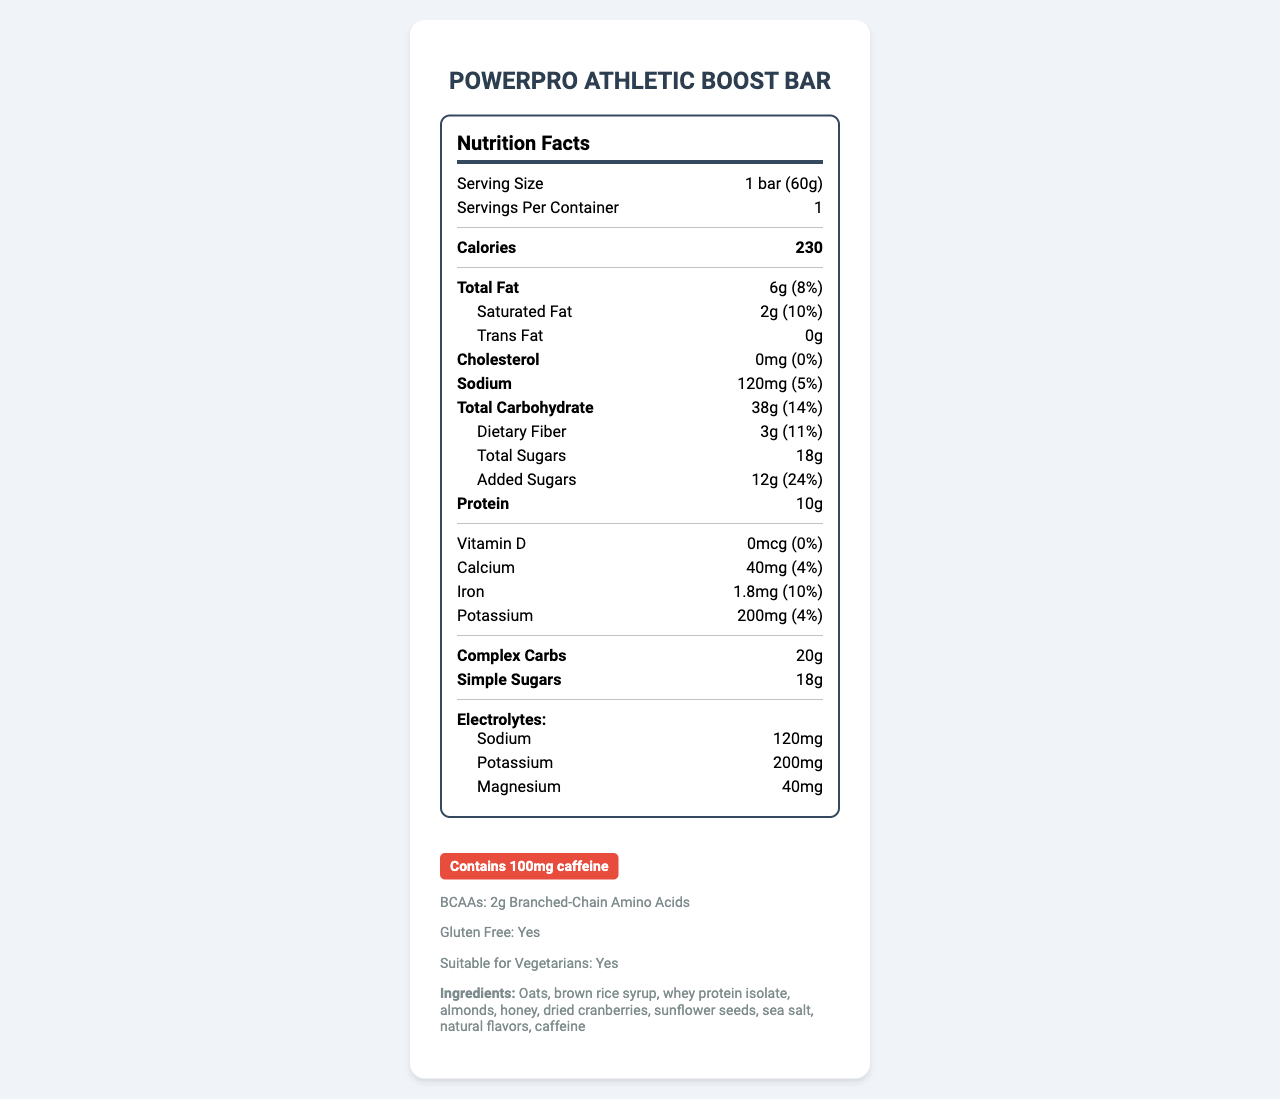what is the serving size of the PowerPro Athletic Boost Bar? The document states that the serving size is 1 bar weighing 60 grams.
Answer: 1 bar (60g) how many calories are in one serving of the energy bar? The document lists the calories per serving as 230.
Answer: 230 how much added sugar is in one serving of the energy bar? The document indicates that the added sugars amount to 12 grams per serving.
Answer: 12g how much protein does one PowerPro Athletic Boost Bar contain? The document states the protein content as 10 grams.
Answer: 10g List the electrolytes provided in this energy bar. The document specifies electrolytes as 120mg sodium, 200mg potassium, and 40mg magnesium.
Answer: Sodium, Potassium, Magnesium how much caffeine is contained in this bar? The additional information section highlights a 100mg caffeine content as part of its pre-workout boost.
Answer: 100mg what is the total carbohydrate content per serving? The document lists the total carbohydrate content as 38 grams.
Answer: 38g how much dietary fiber is in one PowerPro Athletic Boost Bar? The document states that the dietary fiber content is 3 grams.
Answer: 3g what percentage of the daily value is the saturated fat content? The document indicates that the saturated fat content is 10% of the daily value.
Answer: 10% Is the PowerPro Athletic Boost Bar gluten-free? The additional information specifies that the bar is gluten-free.
Answer: Yes how many servings are there per container? According to the document, there is 1 serving per container.
Answer: 1 What is the amount of simple sugars in one serving? A. 10g B. 15g C. 18g The document indicates that the amount of simple sugars in one serving is 18 grams.
Answer: C Which mineral has the highest percentage of the daily value in this bar? A. Calcium B. Iron C. Potassium Iron at 10% has the highest percentage of the daily value compared to calcium at 4% and potassium at 4%.
Answer: B Does this energy bar contain any cholesterol? The document states that the cholesterol content is 0mg, which is 0% of the daily value.
Answer: No Describe the main idea of the document. The document is essentially a comprehensive Nutrition Facts Label and additional information for the PowerPro Athletic Boost Bar, highlighting its ingredients, nutritional values per serving, and other beneficial properties aimed at athletes and active individuals.
Answer: The document provides detailed nutritional information for the PowerPro Athletic Boost Bar, including its serving size, calorie content, macronutrient breakdown, vitamin and mineral content, electrolyte details, and additional features like being gluten-free, vegetarian-friendly, and containing caffeine and BCAAs. It serves as a comprehensive guide to the nutritional value and ingredients of the bar. What is the caloric contribution from fat in this bar? The document does not provide direct information on the caloric contribution from fat, though it lists total fat content.
Answer: Not enough information 